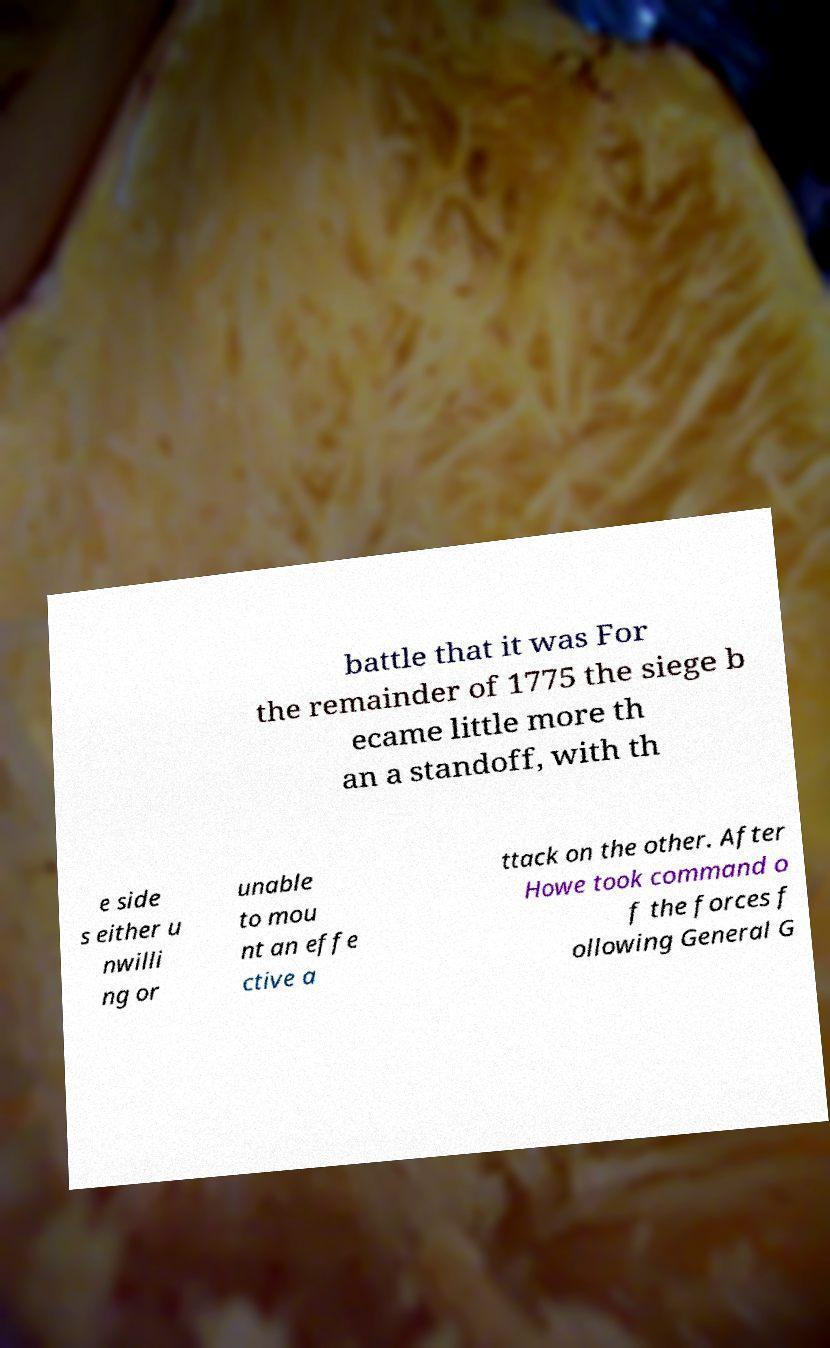What messages or text are displayed in this image? I need them in a readable, typed format. battle that it was For the remainder of 1775 the siege b ecame little more th an a standoff, with th e side s either u nwilli ng or unable to mou nt an effe ctive a ttack on the other. After Howe took command o f the forces f ollowing General G 